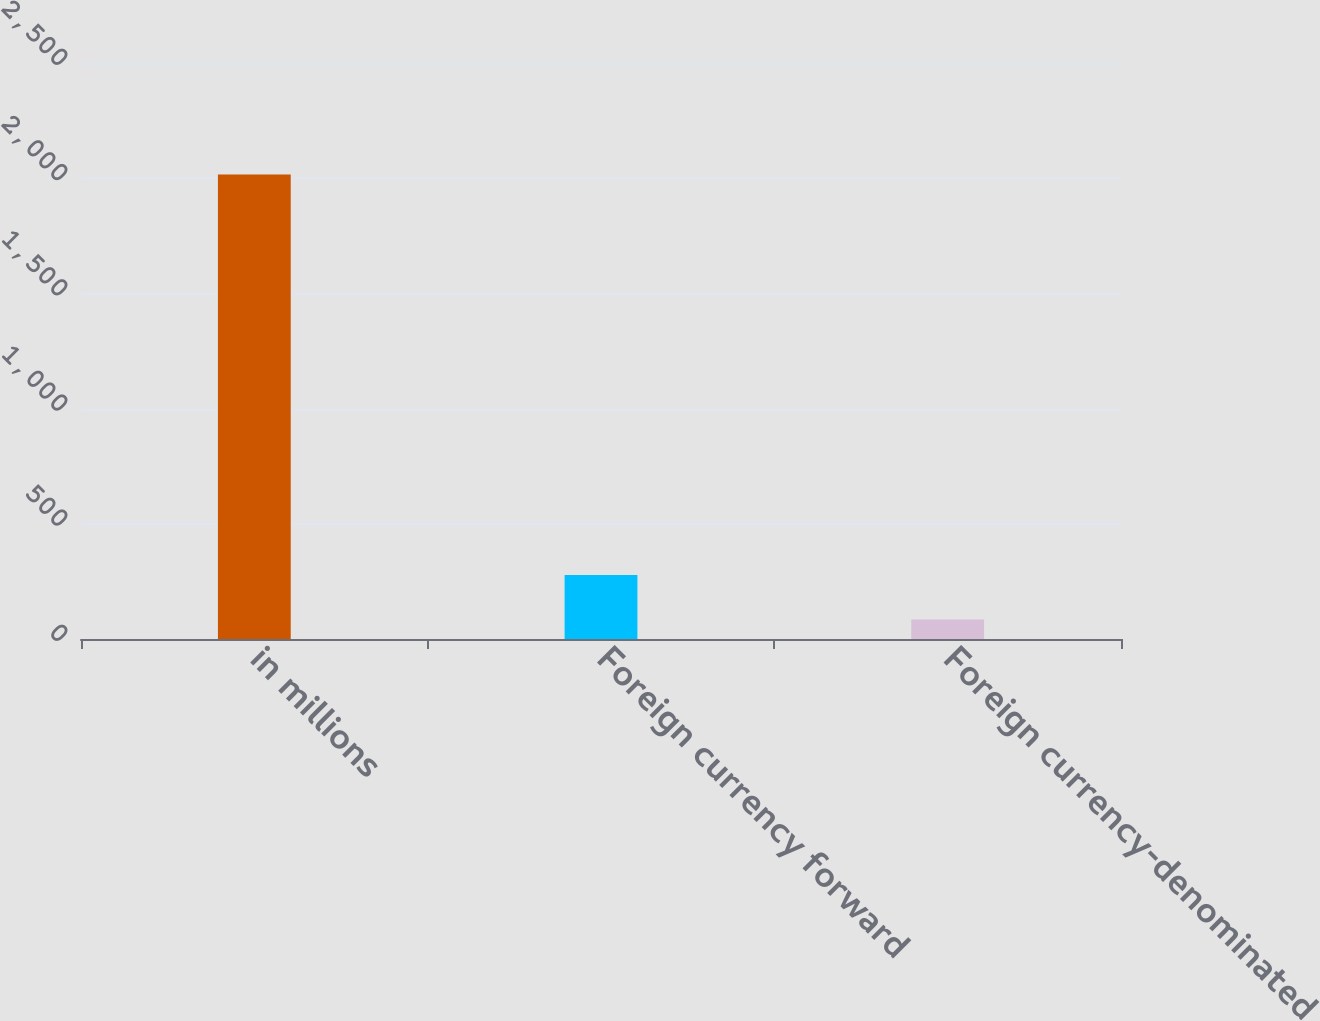Convert chart. <chart><loc_0><loc_0><loc_500><loc_500><bar_chart><fcel>in millions<fcel>Foreign currency forward<fcel>Foreign currency-denominated<nl><fcel>2016<fcel>278.1<fcel>85<nl></chart> 